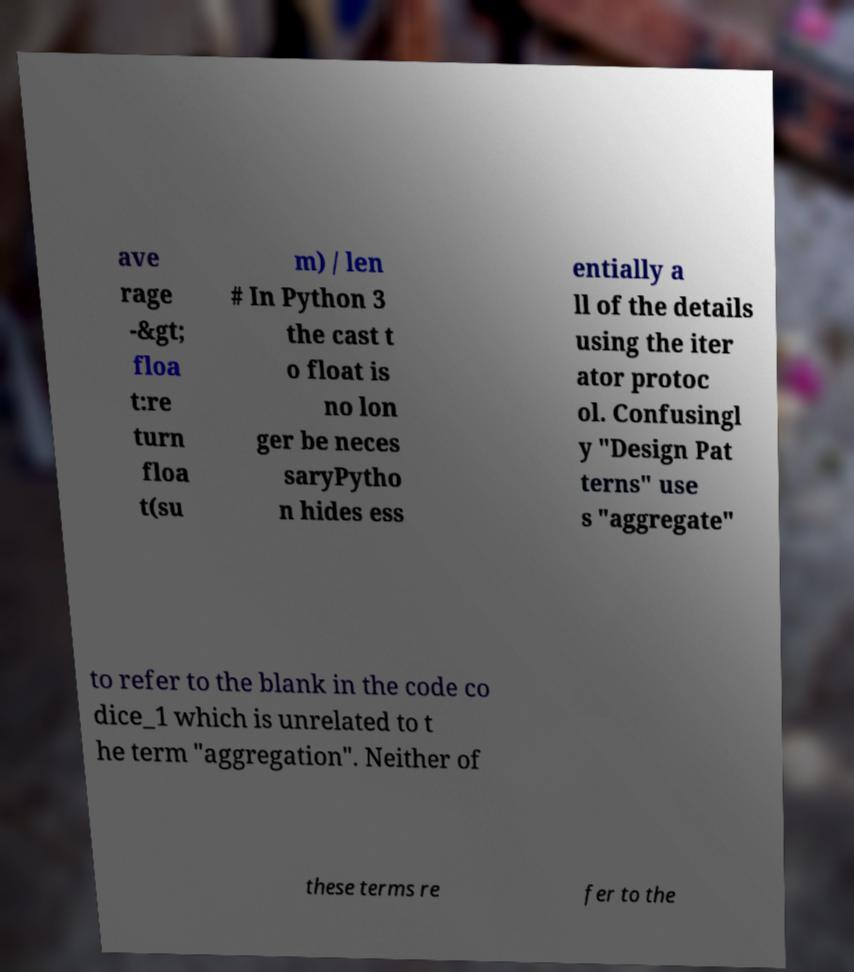Could you assist in decoding the text presented in this image and type it out clearly? ave rage -&gt; floa t:re turn floa t(su m) / len # In Python 3 the cast t o float is no lon ger be neces saryPytho n hides ess entially a ll of the details using the iter ator protoc ol. Confusingl y "Design Pat terns" use s "aggregate" to refer to the blank in the code co dice_1 which is unrelated to t he term "aggregation". Neither of these terms re fer to the 